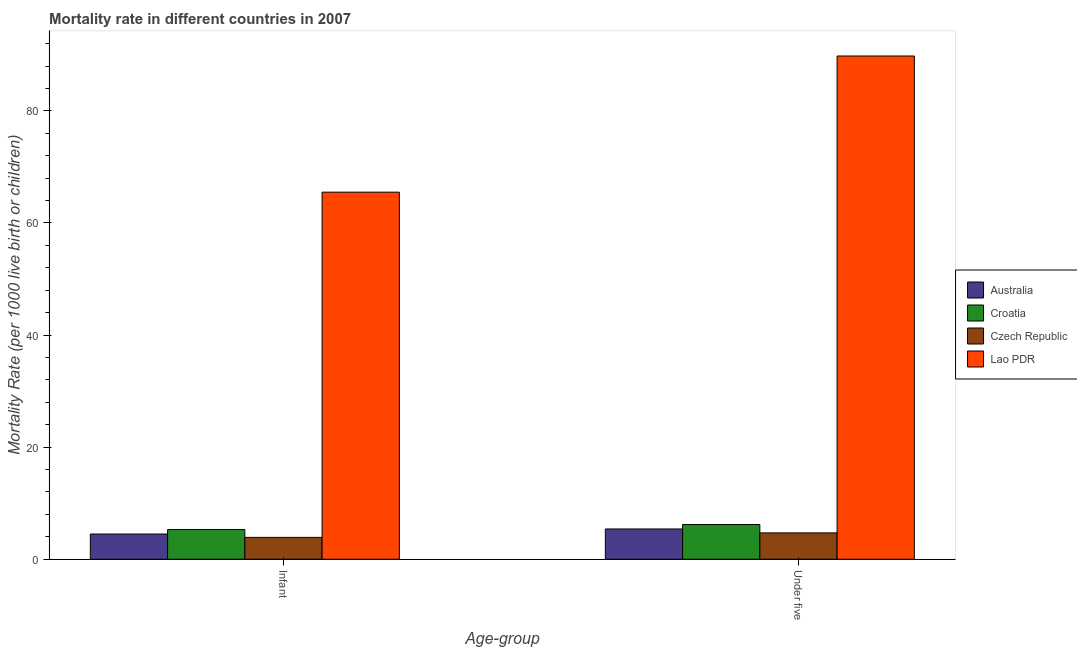How many different coloured bars are there?
Offer a terse response. 4. How many groups of bars are there?
Keep it short and to the point. 2. Are the number of bars on each tick of the X-axis equal?
Keep it short and to the point. Yes. What is the label of the 1st group of bars from the left?
Ensure brevity in your answer.  Infant. Across all countries, what is the maximum under-5 mortality rate?
Give a very brief answer. 89.8. Across all countries, what is the minimum under-5 mortality rate?
Give a very brief answer. 4.7. In which country was the infant mortality rate maximum?
Make the answer very short. Lao PDR. In which country was the under-5 mortality rate minimum?
Make the answer very short. Czech Republic. What is the total under-5 mortality rate in the graph?
Ensure brevity in your answer.  106.1. What is the difference between the infant mortality rate in Lao PDR and that in Australia?
Provide a succinct answer. 61. What is the difference between the under-5 mortality rate in Croatia and the infant mortality rate in Lao PDR?
Provide a succinct answer. -59.3. What is the average infant mortality rate per country?
Ensure brevity in your answer.  19.8. What is the difference between the infant mortality rate and under-5 mortality rate in Lao PDR?
Your answer should be compact. -24.3. In how many countries, is the infant mortality rate greater than 40 ?
Your answer should be very brief. 1. What is the ratio of the under-5 mortality rate in Australia to that in Croatia?
Your answer should be very brief. 0.87. In how many countries, is the under-5 mortality rate greater than the average under-5 mortality rate taken over all countries?
Your answer should be very brief. 1. What does the 3rd bar from the left in Under five represents?
Make the answer very short. Czech Republic. What does the 2nd bar from the right in Under five represents?
Keep it short and to the point. Czech Republic. Are all the bars in the graph horizontal?
Make the answer very short. No. How many countries are there in the graph?
Your answer should be compact. 4. What is the difference between two consecutive major ticks on the Y-axis?
Provide a short and direct response. 20. Are the values on the major ticks of Y-axis written in scientific E-notation?
Your answer should be very brief. No. Does the graph contain any zero values?
Offer a very short reply. No. How many legend labels are there?
Ensure brevity in your answer.  4. What is the title of the graph?
Offer a terse response. Mortality rate in different countries in 2007. Does "Mozambique" appear as one of the legend labels in the graph?
Your response must be concise. No. What is the label or title of the X-axis?
Your answer should be compact. Age-group. What is the label or title of the Y-axis?
Your answer should be very brief. Mortality Rate (per 1000 live birth or children). What is the Mortality Rate (per 1000 live birth or children) in Croatia in Infant?
Make the answer very short. 5.3. What is the Mortality Rate (per 1000 live birth or children) in Czech Republic in Infant?
Offer a terse response. 3.9. What is the Mortality Rate (per 1000 live birth or children) of Lao PDR in Infant?
Keep it short and to the point. 65.5. What is the Mortality Rate (per 1000 live birth or children) in Australia in Under five?
Provide a short and direct response. 5.4. What is the Mortality Rate (per 1000 live birth or children) of Czech Republic in Under five?
Give a very brief answer. 4.7. What is the Mortality Rate (per 1000 live birth or children) in Lao PDR in Under five?
Your response must be concise. 89.8. Across all Age-group, what is the maximum Mortality Rate (per 1000 live birth or children) of Australia?
Keep it short and to the point. 5.4. Across all Age-group, what is the maximum Mortality Rate (per 1000 live birth or children) in Lao PDR?
Give a very brief answer. 89.8. Across all Age-group, what is the minimum Mortality Rate (per 1000 live birth or children) of Lao PDR?
Offer a very short reply. 65.5. What is the total Mortality Rate (per 1000 live birth or children) in Australia in the graph?
Give a very brief answer. 9.9. What is the total Mortality Rate (per 1000 live birth or children) of Croatia in the graph?
Give a very brief answer. 11.5. What is the total Mortality Rate (per 1000 live birth or children) of Lao PDR in the graph?
Ensure brevity in your answer.  155.3. What is the difference between the Mortality Rate (per 1000 live birth or children) of Australia in Infant and that in Under five?
Provide a short and direct response. -0.9. What is the difference between the Mortality Rate (per 1000 live birth or children) in Czech Republic in Infant and that in Under five?
Ensure brevity in your answer.  -0.8. What is the difference between the Mortality Rate (per 1000 live birth or children) of Lao PDR in Infant and that in Under five?
Make the answer very short. -24.3. What is the difference between the Mortality Rate (per 1000 live birth or children) in Australia in Infant and the Mortality Rate (per 1000 live birth or children) in Czech Republic in Under five?
Offer a very short reply. -0.2. What is the difference between the Mortality Rate (per 1000 live birth or children) of Australia in Infant and the Mortality Rate (per 1000 live birth or children) of Lao PDR in Under five?
Your response must be concise. -85.3. What is the difference between the Mortality Rate (per 1000 live birth or children) of Croatia in Infant and the Mortality Rate (per 1000 live birth or children) of Czech Republic in Under five?
Offer a very short reply. 0.6. What is the difference between the Mortality Rate (per 1000 live birth or children) in Croatia in Infant and the Mortality Rate (per 1000 live birth or children) in Lao PDR in Under five?
Your answer should be very brief. -84.5. What is the difference between the Mortality Rate (per 1000 live birth or children) of Czech Republic in Infant and the Mortality Rate (per 1000 live birth or children) of Lao PDR in Under five?
Your answer should be compact. -85.9. What is the average Mortality Rate (per 1000 live birth or children) of Australia per Age-group?
Provide a succinct answer. 4.95. What is the average Mortality Rate (per 1000 live birth or children) in Croatia per Age-group?
Give a very brief answer. 5.75. What is the average Mortality Rate (per 1000 live birth or children) in Czech Republic per Age-group?
Make the answer very short. 4.3. What is the average Mortality Rate (per 1000 live birth or children) in Lao PDR per Age-group?
Give a very brief answer. 77.65. What is the difference between the Mortality Rate (per 1000 live birth or children) in Australia and Mortality Rate (per 1000 live birth or children) in Croatia in Infant?
Make the answer very short. -0.8. What is the difference between the Mortality Rate (per 1000 live birth or children) of Australia and Mortality Rate (per 1000 live birth or children) of Lao PDR in Infant?
Your answer should be compact. -61. What is the difference between the Mortality Rate (per 1000 live birth or children) in Croatia and Mortality Rate (per 1000 live birth or children) in Lao PDR in Infant?
Keep it short and to the point. -60.2. What is the difference between the Mortality Rate (per 1000 live birth or children) of Czech Republic and Mortality Rate (per 1000 live birth or children) of Lao PDR in Infant?
Ensure brevity in your answer.  -61.6. What is the difference between the Mortality Rate (per 1000 live birth or children) in Australia and Mortality Rate (per 1000 live birth or children) in Croatia in Under five?
Keep it short and to the point. -0.8. What is the difference between the Mortality Rate (per 1000 live birth or children) in Australia and Mortality Rate (per 1000 live birth or children) in Czech Republic in Under five?
Make the answer very short. 0.7. What is the difference between the Mortality Rate (per 1000 live birth or children) of Australia and Mortality Rate (per 1000 live birth or children) of Lao PDR in Under five?
Ensure brevity in your answer.  -84.4. What is the difference between the Mortality Rate (per 1000 live birth or children) in Croatia and Mortality Rate (per 1000 live birth or children) in Czech Republic in Under five?
Keep it short and to the point. 1.5. What is the difference between the Mortality Rate (per 1000 live birth or children) in Croatia and Mortality Rate (per 1000 live birth or children) in Lao PDR in Under five?
Offer a terse response. -83.6. What is the difference between the Mortality Rate (per 1000 live birth or children) of Czech Republic and Mortality Rate (per 1000 live birth or children) of Lao PDR in Under five?
Your answer should be compact. -85.1. What is the ratio of the Mortality Rate (per 1000 live birth or children) in Croatia in Infant to that in Under five?
Your answer should be compact. 0.85. What is the ratio of the Mortality Rate (per 1000 live birth or children) in Czech Republic in Infant to that in Under five?
Provide a succinct answer. 0.83. What is the ratio of the Mortality Rate (per 1000 live birth or children) of Lao PDR in Infant to that in Under five?
Your answer should be very brief. 0.73. What is the difference between the highest and the second highest Mortality Rate (per 1000 live birth or children) of Lao PDR?
Your answer should be very brief. 24.3. What is the difference between the highest and the lowest Mortality Rate (per 1000 live birth or children) in Croatia?
Offer a very short reply. 0.9. What is the difference between the highest and the lowest Mortality Rate (per 1000 live birth or children) in Czech Republic?
Keep it short and to the point. 0.8. What is the difference between the highest and the lowest Mortality Rate (per 1000 live birth or children) of Lao PDR?
Provide a short and direct response. 24.3. 